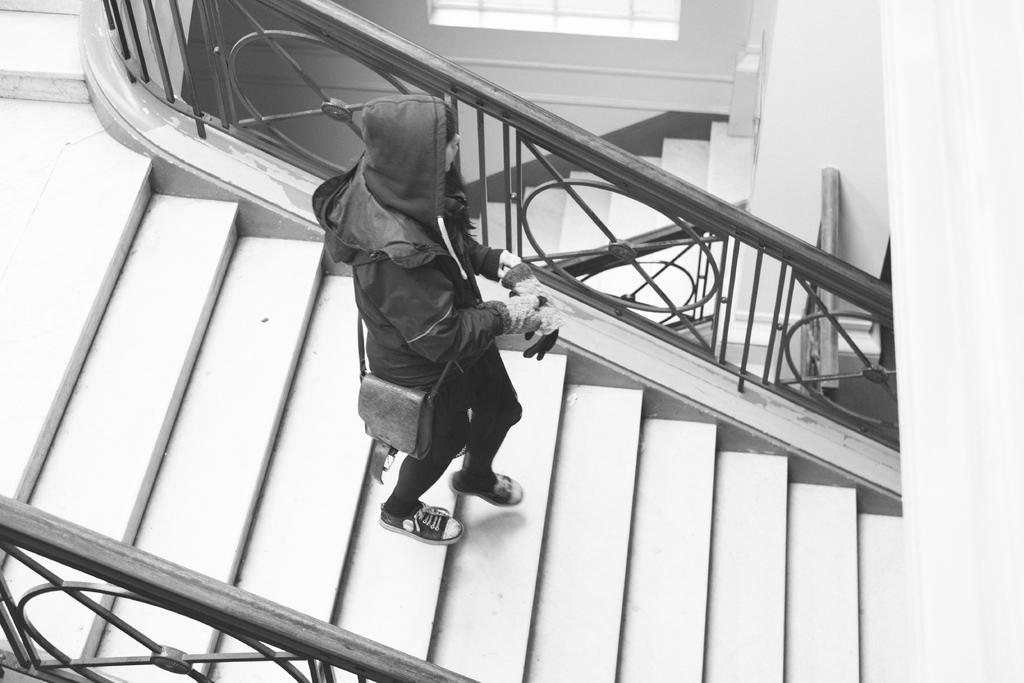What is the person in the image doing? There is a person walking on the staircase in the image. What feature is present on both sides of the staircase? There is railing on both sides of the staircase. What can be seen at the back of the image? There appears to be a door at the back of the image. Is there any source of natural light in the image? Yes, there is a window in the image. What type of pipe is visible in the image? There is no pipe present in the image. What architectural feature can be seen above the door in the image? There is no specific architectural feature mentioned above the door in the image. 